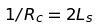Convert formula to latex. <formula><loc_0><loc_0><loc_500><loc_500>1 / R _ { c } = 2 L _ { s }</formula> 